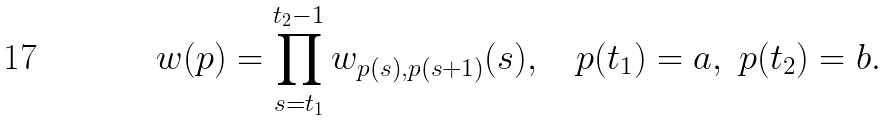Convert formula to latex. <formula><loc_0><loc_0><loc_500><loc_500>w ( p ) = \prod _ { s = t _ { 1 } } ^ { t _ { 2 } - 1 } w _ { p ( s ) , p ( s + 1 ) } ( s ) , \quad p ( t _ { 1 } ) = a , \ p ( t _ { 2 } ) = b .</formula> 